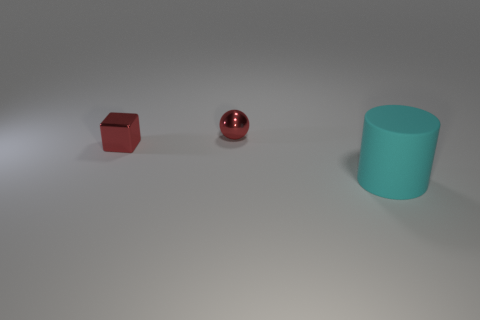Add 1 red shiny objects. How many objects exist? 4 Subtract all blocks. How many objects are left? 2 Add 2 cylinders. How many cylinders are left? 3 Add 3 big objects. How many big objects exist? 4 Subtract 0 brown blocks. How many objects are left? 3 Subtract 1 spheres. How many spheres are left? 0 Subtract all green blocks. Subtract all blue cylinders. How many blocks are left? 1 Subtract all green rubber cylinders. Subtract all large cyan matte things. How many objects are left? 2 